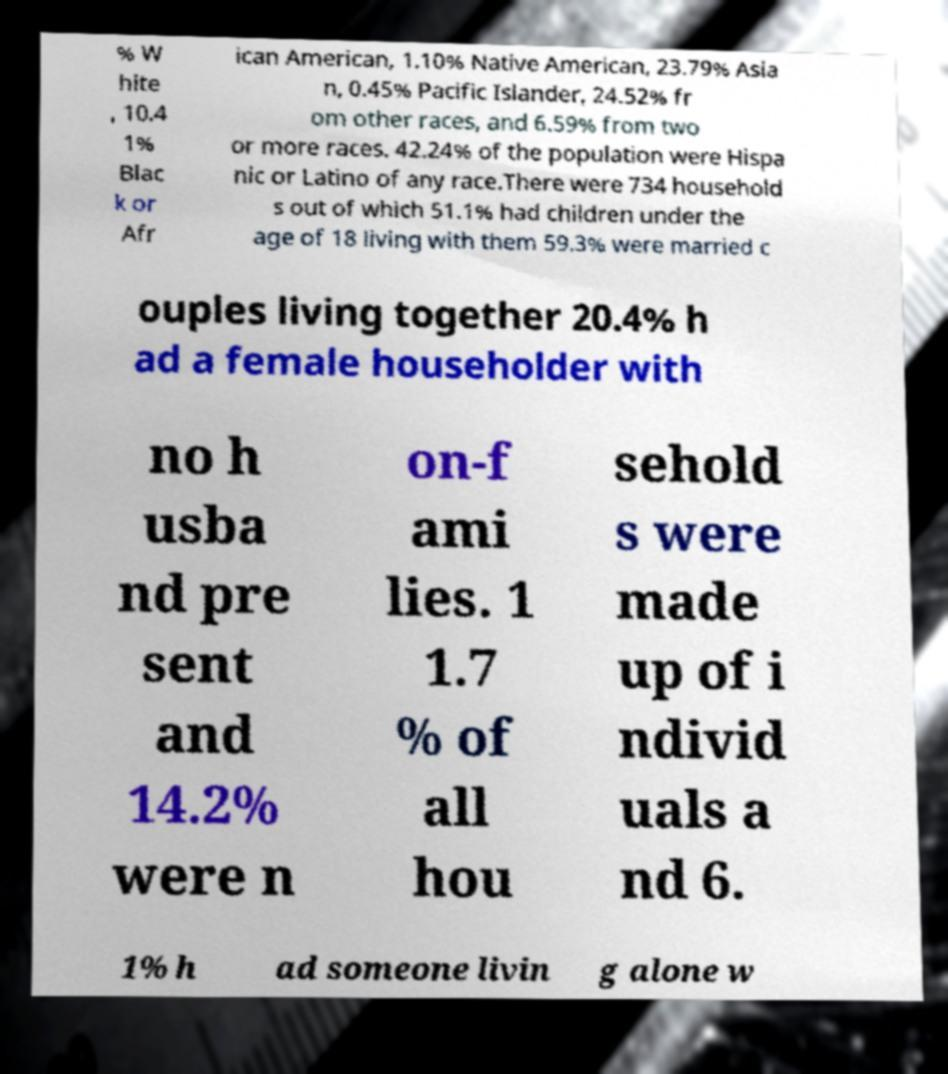Could you extract and type out the text from this image? % W hite , 10.4 1% Blac k or Afr ican American, 1.10% Native American, 23.79% Asia n, 0.45% Pacific Islander, 24.52% fr om other races, and 6.59% from two or more races. 42.24% of the population were Hispa nic or Latino of any race.There were 734 household s out of which 51.1% had children under the age of 18 living with them 59.3% were married c ouples living together 20.4% h ad a female householder with no h usba nd pre sent and 14.2% were n on-f ami lies. 1 1.7 % of all hou sehold s were made up of i ndivid uals a nd 6. 1% h ad someone livin g alone w 